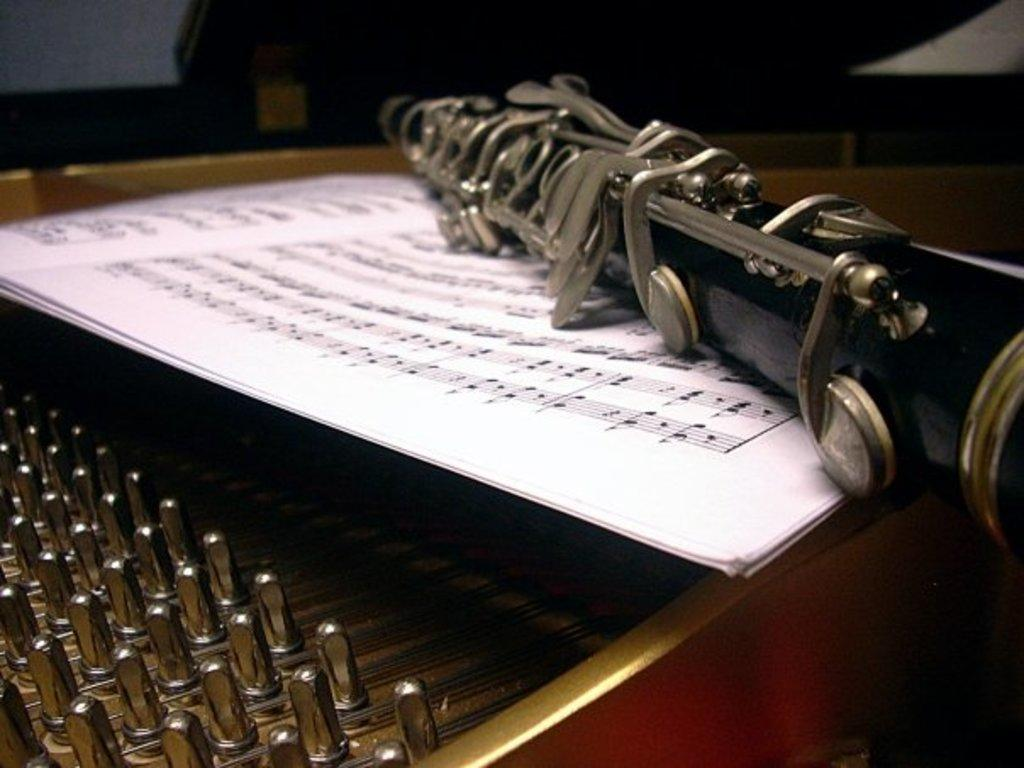What objects in the image are related to music? There are two musical instruments in the image. What colors can be seen on the musical instruments? The musical instruments are in black, silver, and red colors. What is placed on the musical instruments? There are white color papers on the musical instruments. Can you see any flies on the musical instruments in the image? There are no flies visible in the image. What type of flowers are present on the musical instruments in the image? There are no flowers present on the musical instruments in the image. 